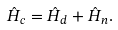<formula> <loc_0><loc_0><loc_500><loc_500>\hat { H } _ { c } = \hat { H } _ { d } + \hat { H } _ { n } .</formula> 